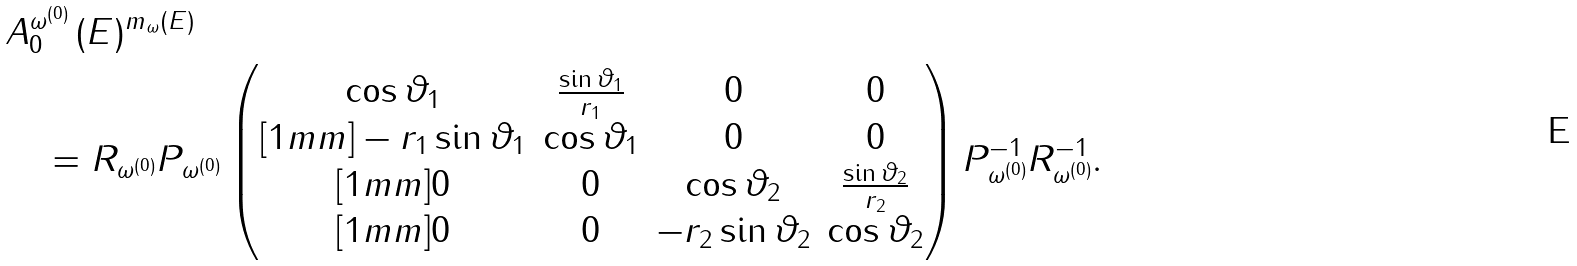<formula> <loc_0><loc_0><loc_500><loc_500>& A _ { 0 } ^ { \omega ^ { ( 0 ) } } \, ( E ) ^ { m _ { \omega } ( E ) } \\ & \quad = R _ { \omega ^ { ( 0 ) } } P _ { \omega ^ { ( 0 ) } } \begin{pmatrix} \cos \vartheta _ { 1 } & \frac { \sin \vartheta _ { 1 } } { r _ { 1 } } & 0 & 0 \\ [ 1 m m ] - r _ { 1 } \sin \vartheta _ { 1 } & \cos \vartheta _ { 1 } & 0 & 0 \\ [ 1 m m ] 0 & 0 & \cos \vartheta _ { 2 } & \frac { \sin \vartheta _ { 2 } } { r _ { 2 } } \\ [ 1 m m ] 0 & 0 & - r _ { 2 } \sin \vartheta _ { 2 } & \cos \vartheta _ { 2 } \end{pmatrix} P _ { \omega ^ { ( 0 ) } } ^ { - 1 } R _ { \omega ^ { ( 0 ) } } ^ { - 1 } .</formula> 